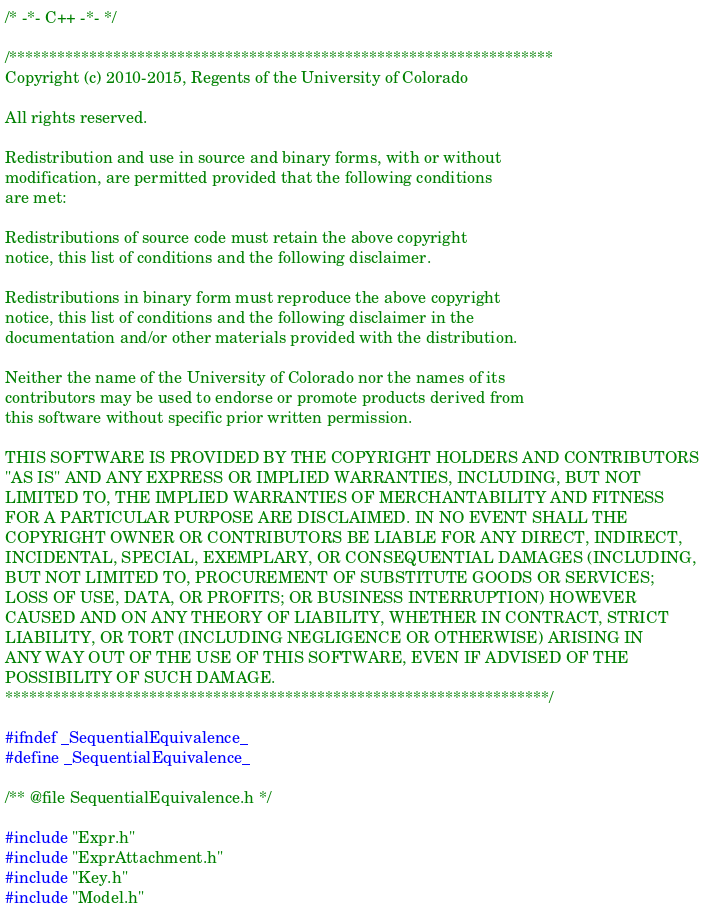<code> <loc_0><loc_0><loc_500><loc_500><_C_>/* -*- C++ -*- */

/********************************************************************
Copyright (c) 2010-2015, Regents of the University of Colorado

All rights reserved.

Redistribution and use in source and binary forms, with or without
modification, are permitted provided that the following conditions
are met:

Redistributions of source code must retain the above copyright
notice, this list of conditions and the following disclaimer.

Redistributions in binary form must reproduce the above copyright
notice, this list of conditions and the following disclaimer in the
documentation and/or other materials provided with the distribution.

Neither the name of the University of Colorado nor the names of its
contributors may be used to endorse or promote products derived from
this software without specific prior written permission.

THIS SOFTWARE IS PROVIDED BY THE COPYRIGHT HOLDERS AND CONTRIBUTORS
"AS IS" AND ANY EXPRESS OR IMPLIED WARRANTIES, INCLUDING, BUT NOT
LIMITED TO, THE IMPLIED WARRANTIES OF MERCHANTABILITY AND FITNESS
FOR A PARTICULAR PURPOSE ARE DISCLAIMED. IN NO EVENT SHALL THE
COPYRIGHT OWNER OR CONTRIBUTORS BE LIABLE FOR ANY DIRECT, INDIRECT,
INCIDENTAL, SPECIAL, EXEMPLARY, OR CONSEQUENTIAL DAMAGES (INCLUDING,
BUT NOT LIMITED TO, PROCUREMENT OF SUBSTITUTE GOODS OR SERVICES;
LOSS OF USE, DATA, OR PROFITS; OR BUSINESS INTERRUPTION) HOWEVER
CAUSED AND ON ANY THEORY OF LIABILITY, WHETHER IN CONTRACT, STRICT
LIABILITY, OR TORT (INCLUDING NEGLIGENCE OR OTHERWISE) ARISING IN
ANY WAY OUT OF THE USE OF THIS SOFTWARE, EVEN IF ADVISED OF THE
POSSIBILITY OF SUCH DAMAGE.
********************************************************************/

#ifndef _SequentialEquivalence_
#define _SequentialEquivalence_

/** @file SequentialEquivalence.h */

#include "Expr.h"
#include "ExprAttachment.h"
#include "Key.h"
#include "Model.h"</code> 